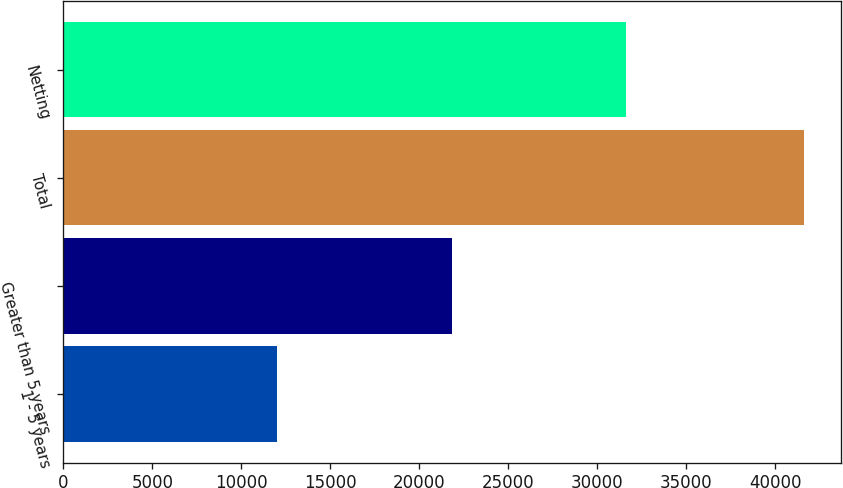Convert chart to OTSL. <chart><loc_0><loc_0><loc_500><loc_500><bar_chart><fcel>1 - 5 years<fcel>Greater than 5 years<fcel>Total<fcel>Netting<nl><fcel>11975<fcel>21857<fcel>41638<fcel>31644<nl></chart> 